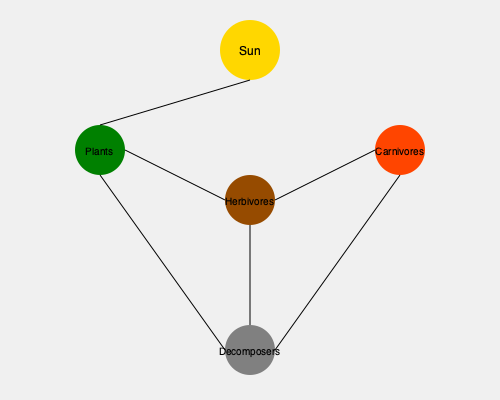In this food web diagram, which organism plays a crucial role in recycling nutrients and completing the energy cycle within the ecosystem? To answer this question, we need to analyze the roles of each organism in the food web:

1. Sun: The primary energy source for the ecosystem.
2. Plants: Primary producers that convert solar energy into chemical energy through photosynthesis.
3. Herbivores: Primary consumers that feed on plants.
4. Carnivores: Secondary consumers that feed on herbivores.
5. Decomposers: Organisms that break down dead organic matter from all trophic levels.

The key to identifying the organism that plays a crucial role in recycling nutrients and completing the energy cycle is to look for the component that connects back to multiple levels of the food web.

In this diagram, we can see that the Decomposers (at the bottom) have connections to Plants, Herbivores, and Carnivores. This indicates that they break down dead organic matter from all these trophic levels.

Decomposers are essential because they:
1. Break down dead organisms and waste products
2. Release nutrients back into the ecosystem
3. Make these nutrients available for plants to reuse
4. Complete the nutrient cycle, ensuring the continuous flow of energy and matter in the ecosystem

Therefore, the Decomposers play the crucial role in recycling nutrients and completing the energy cycle within this ecosystem.
Answer: Decomposers 